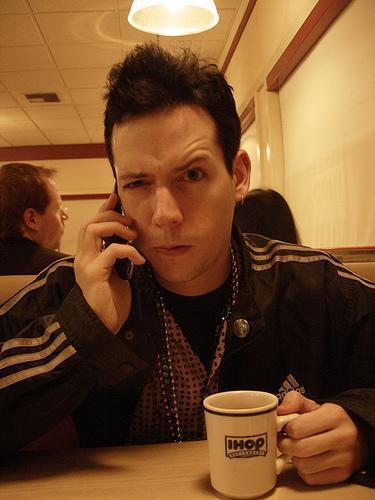How many people are in the photo?
Give a very brief answer. 3. 